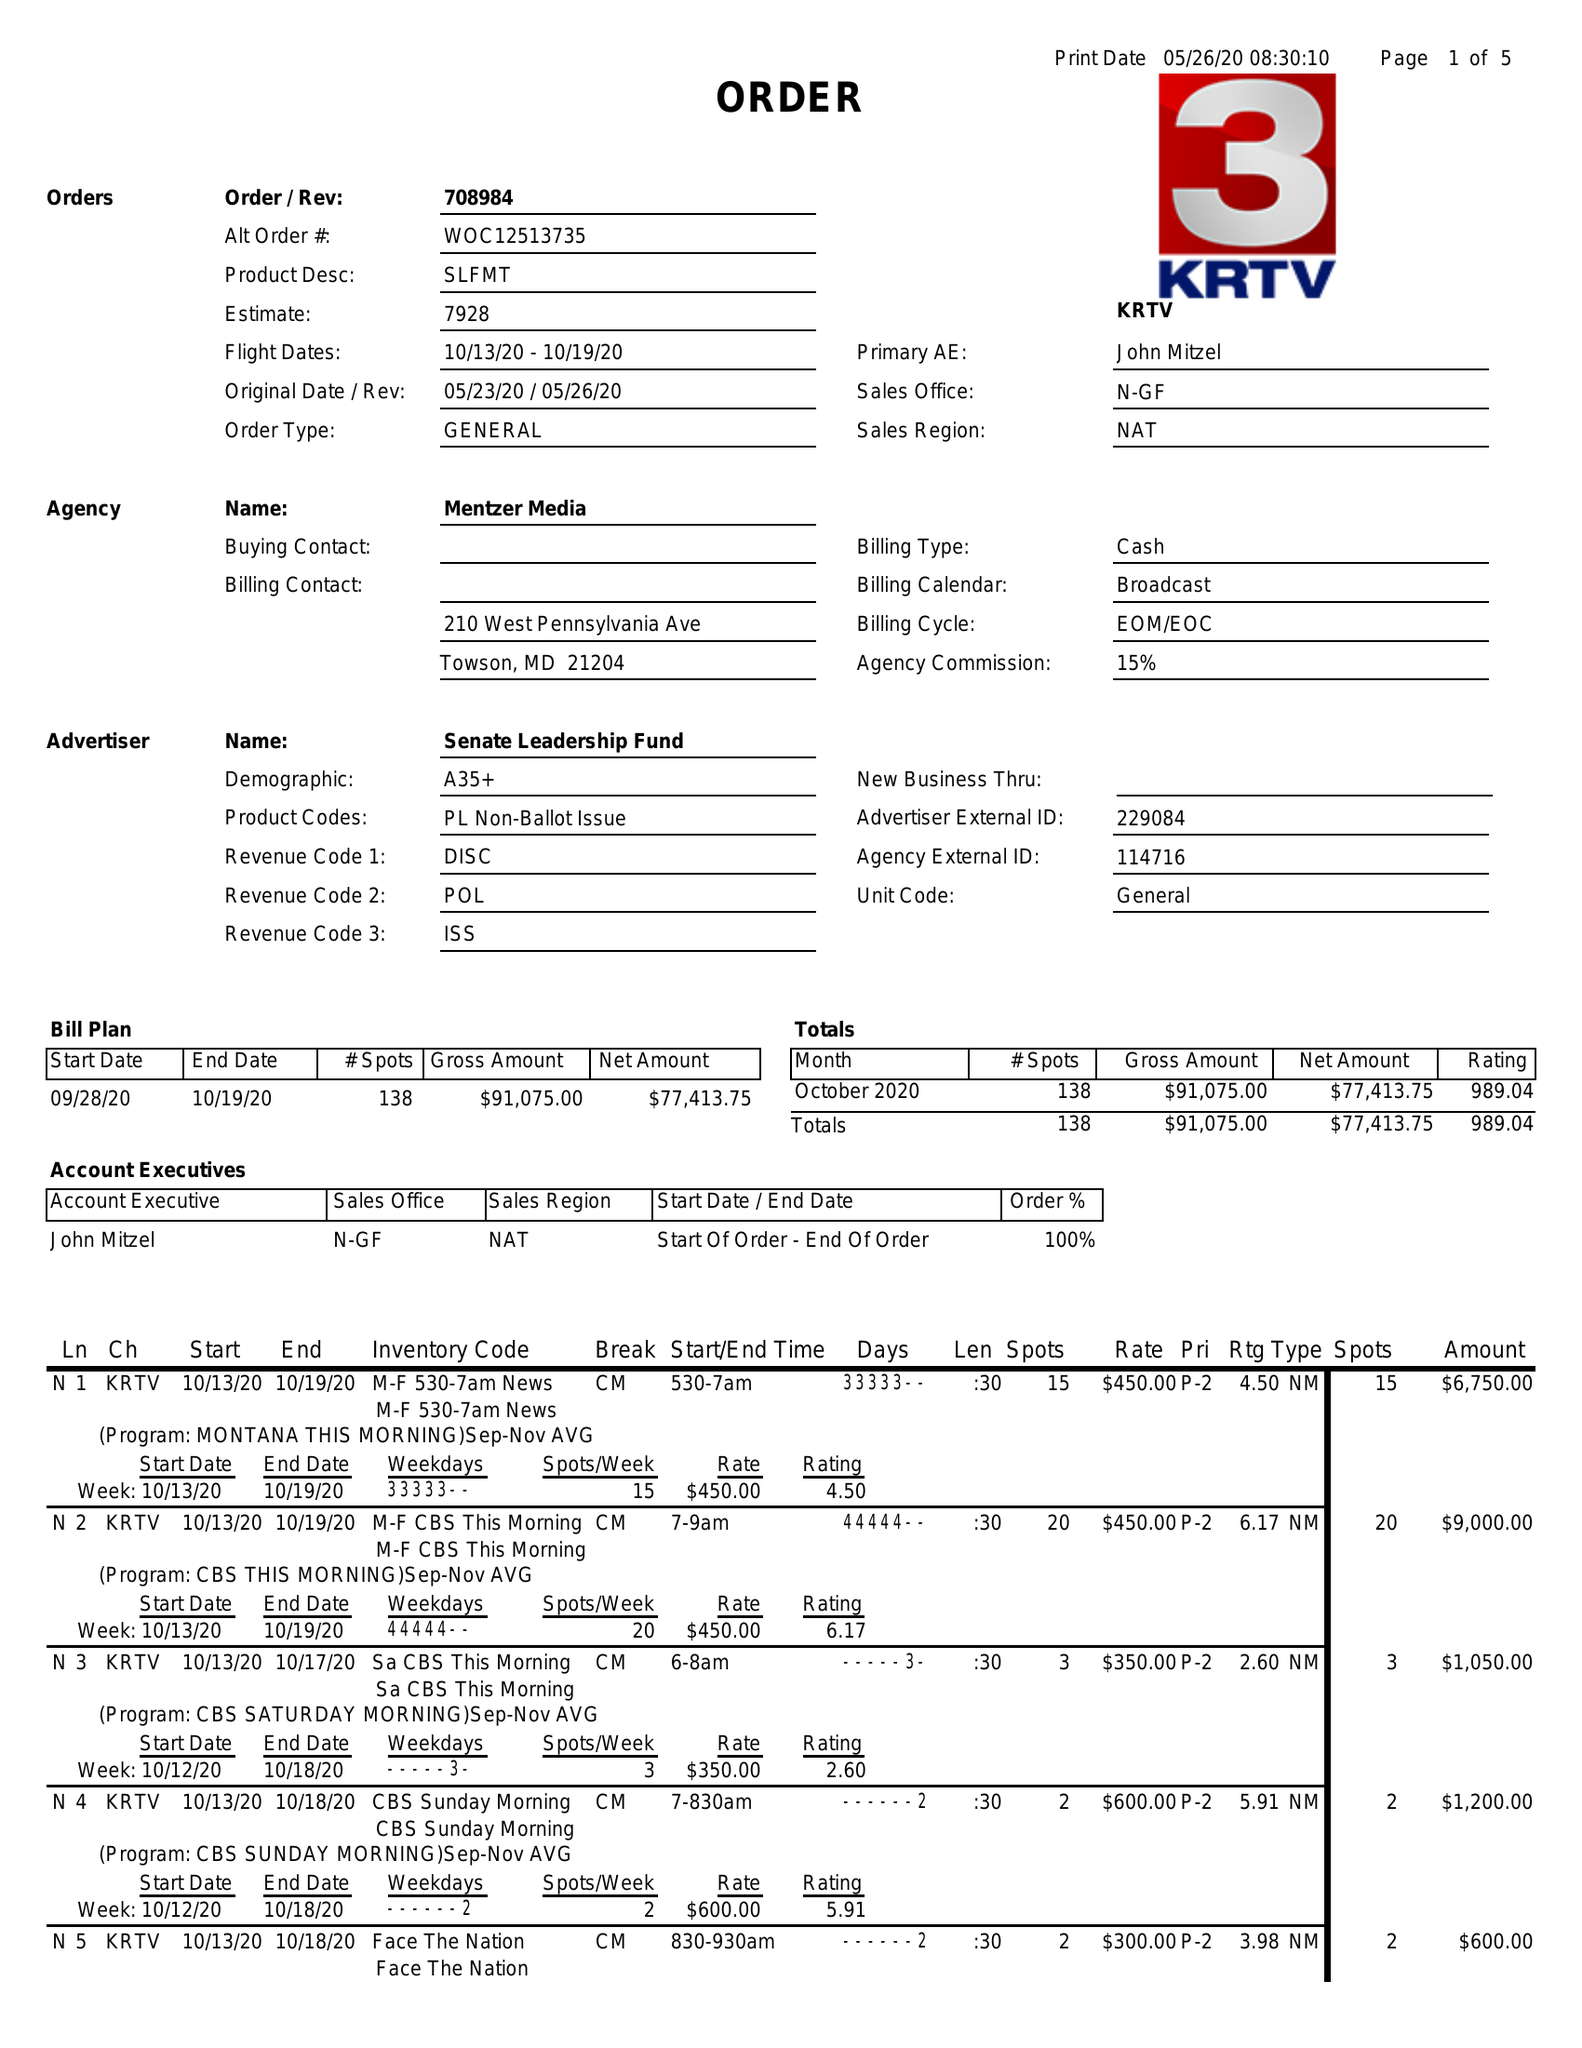What is the value for the gross_amount?
Answer the question using a single word or phrase. 91075.00 